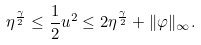Convert formula to latex. <formula><loc_0><loc_0><loc_500><loc_500>\eta ^ { \frac { \gamma } { 2 } } \leq \frac { 1 } { 2 } u ^ { 2 } \leq 2 \eta ^ { \frac { \gamma } { 2 } } + \| \varphi \| _ { \infty } .</formula> 